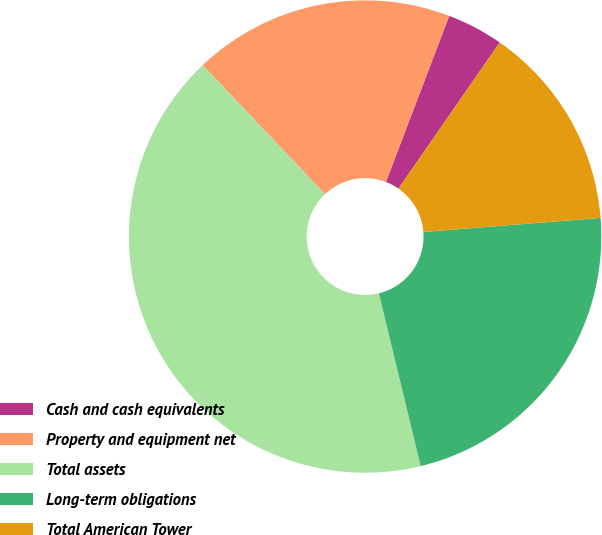Convert chart. <chart><loc_0><loc_0><loc_500><loc_500><pie_chart><fcel>Cash and cash equivalents<fcel>Property and equipment net<fcel>Total assets<fcel>Long-term obligations<fcel>Total American Tower<nl><fcel>3.86%<fcel>17.87%<fcel>41.71%<fcel>22.48%<fcel>14.09%<nl></chart> 